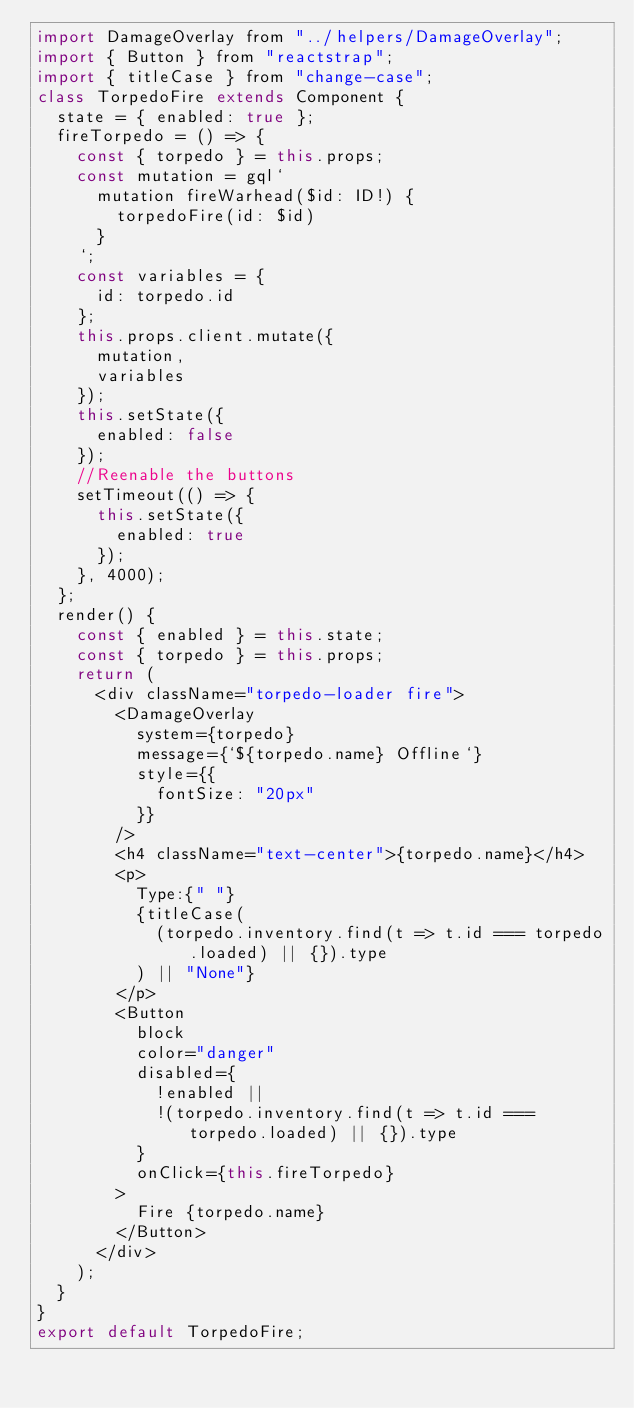Convert code to text. <code><loc_0><loc_0><loc_500><loc_500><_JavaScript_>import DamageOverlay from "../helpers/DamageOverlay";
import { Button } from "reactstrap";
import { titleCase } from "change-case";
class TorpedoFire extends Component {
  state = { enabled: true };
  fireTorpedo = () => {
    const { torpedo } = this.props;
    const mutation = gql`
      mutation fireWarhead($id: ID!) {
        torpedoFire(id: $id)
      }
    `;
    const variables = {
      id: torpedo.id
    };
    this.props.client.mutate({
      mutation,
      variables
    });
    this.setState({
      enabled: false
    });
    //Reenable the buttons
    setTimeout(() => {
      this.setState({
        enabled: true
      });
    }, 4000);
  };
  render() {
    const { enabled } = this.state;
    const { torpedo } = this.props;
    return (
      <div className="torpedo-loader fire">
        <DamageOverlay
          system={torpedo}
          message={`${torpedo.name} Offline`}
          style={{
            fontSize: "20px"
          }}
        />
        <h4 className="text-center">{torpedo.name}</h4>
        <p>
          Type:{" "}
          {titleCase(
            (torpedo.inventory.find(t => t.id === torpedo.loaded) || {}).type
          ) || "None"}
        </p>
        <Button
          block
          color="danger"
          disabled={
            !enabled ||
            !(torpedo.inventory.find(t => t.id === torpedo.loaded) || {}).type
          }
          onClick={this.fireTorpedo}
        >
          Fire {torpedo.name}
        </Button>
      </div>
    );
  }
}
export default TorpedoFire;
</code> 